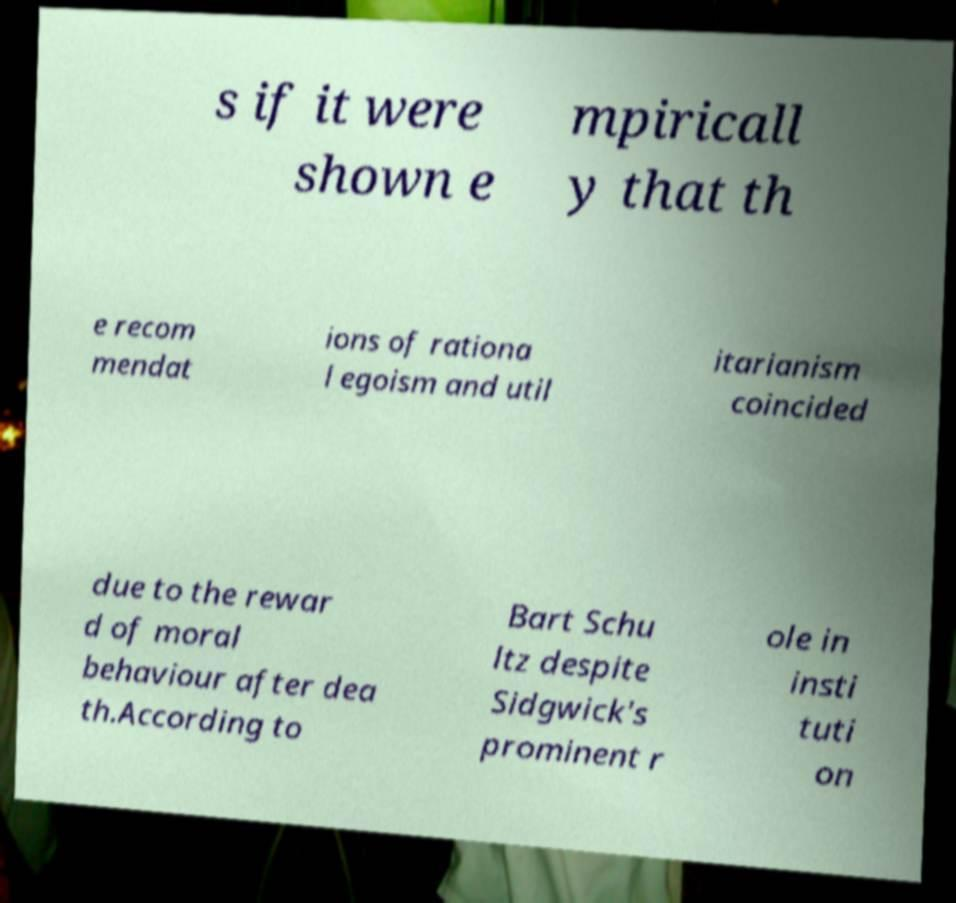For documentation purposes, I need the text within this image transcribed. Could you provide that? s if it were shown e mpiricall y that th e recom mendat ions of rationa l egoism and util itarianism coincided due to the rewar d of moral behaviour after dea th.According to Bart Schu ltz despite Sidgwick's prominent r ole in insti tuti on 